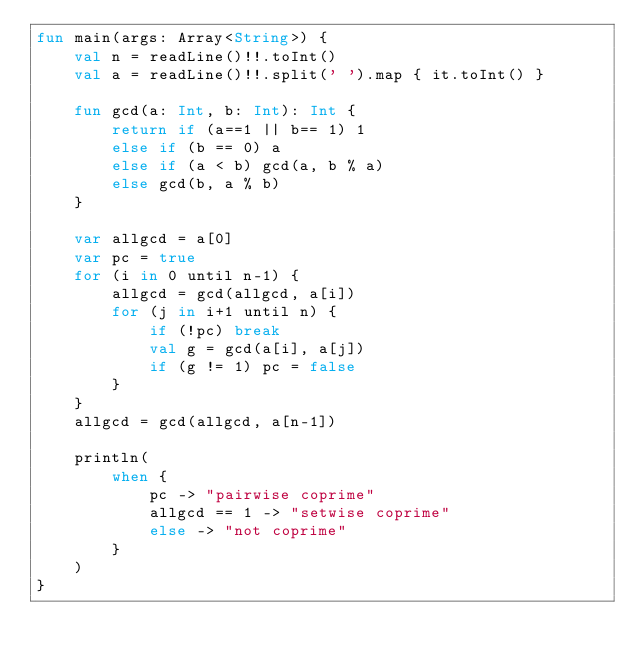<code> <loc_0><loc_0><loc_500><loc_500><_Kotlin_>fun main(args: Array<String>) {
    val n = readLine()!!.toInt()
    val a = readLine()!!.split(' ').map { it.toInt() }

    fun gcd(a: Int, b: Int): Int {
        return if (a==1 || b== 1) 1
        else if (b == 0) a
        else if (a < b) gcd(a, b % a)
        else gcd(b, a % b)
    }

    var allgcd = a[0]
    var pc = true
    for (i in 0 until n-1) {
        allgcd = gcd(allgcd, a[i])
        for (j in i+1 until n) {
            if (!pc) break
            val g = gcd(a[i], a[j])
            if (g != 1) pc = false
        }
    }
    allgcd = gcd(allgcd, a[n-1])

    println(
        when {
            pc -> "pairwise coprime"
            allgcd == 1 -> "setwise coprime"
            else -> "not coprime"
        }
    )
}
</code> 